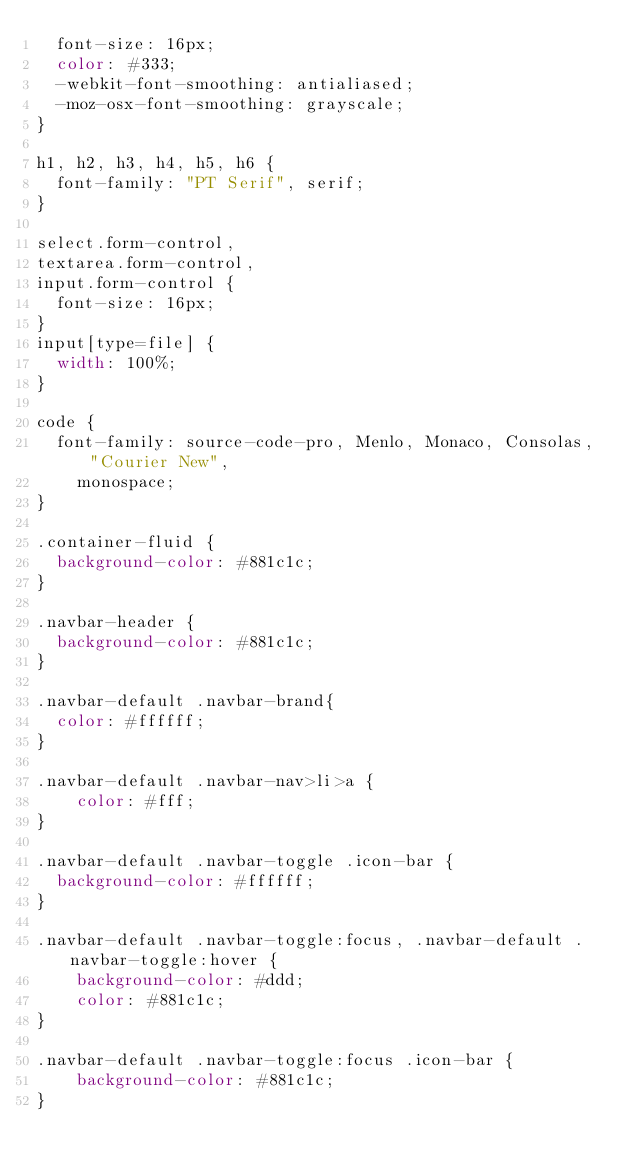Convert code to text. <code><loc_0><loc_0><loc_500><loc_500><_CSS_>  font-size: 16px;
  color: #333;
  -webkit-font-smoothing: antialiased;
  -moz-osx-font-smoothing: grayscale;
}

h1, h2, h3, h4, h5, h6 {
  font-family: "PT Serif", serif;
}

select.form-control,
textarea.form-control,
input.form-control {
  font-size: 16px;
}
input[type=file] {
  width: 100%;
}

code {
  font-family: source-code-pro, Menlo, Monaco, Consolas, "Courier New",
    monospace;
}

.container-fluid {
  background-color: #881c1c;
}

.navbar-header {
  background-color: #881c1c;
}

.navbar-default .navbar-brand{
  color: #ffffff;
}

.navbar-default .navbar-nav>li>a {
    color: #fff;
}

.navbar-default .navbar-toggle .icon-bar {
  background-color: #ffffff;
}

.navbar-default .navbar-toggle:focus, .navbar-default .navbar-toggle:hover {
    background-color: #ddd;
    color: #881c1c;
}

.navbar-default .navbar-toggle:focus .icon-bar {
    background-color: #881c1c;
}
</code> 